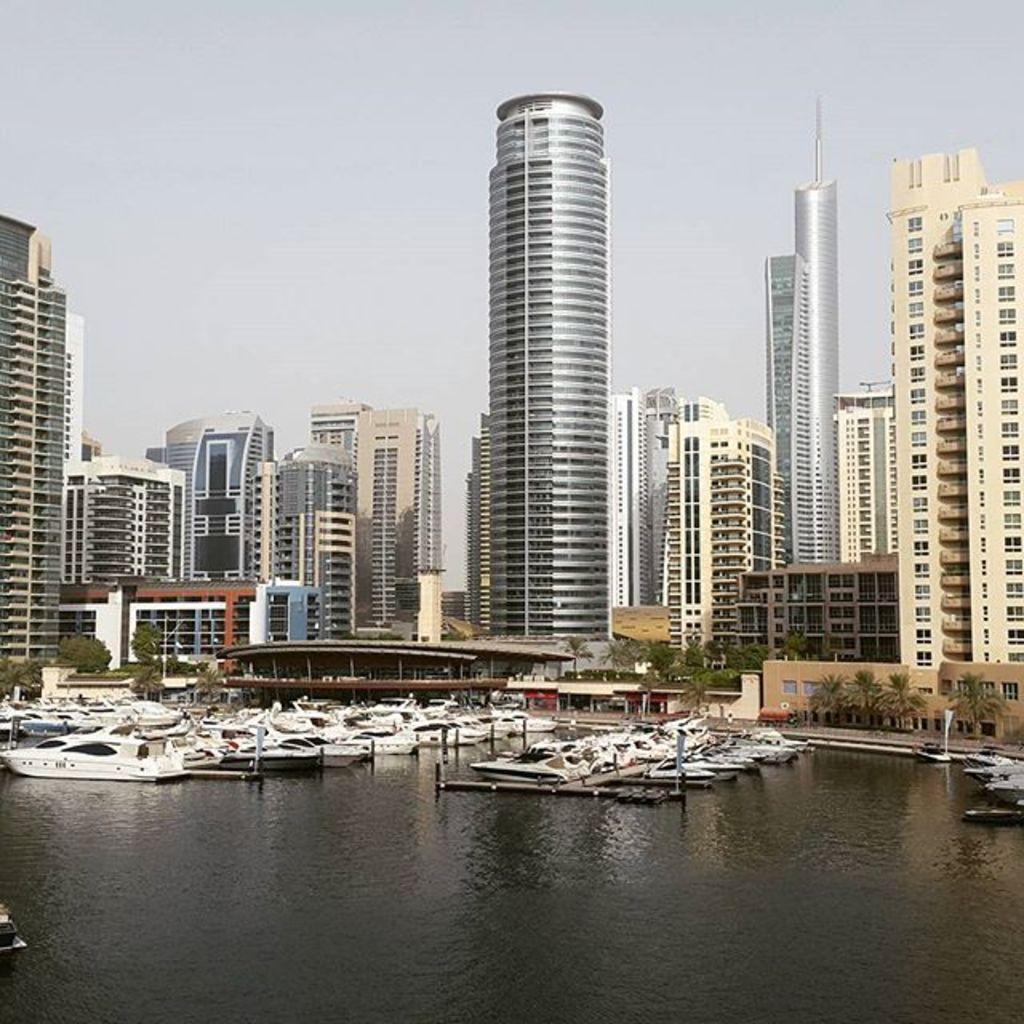In one or two sentences, can you explain what this image depicts? This image consists of buildings and skyscrapers. At the bottom, there is water on which there are many boats. At the top, there is a sky. 